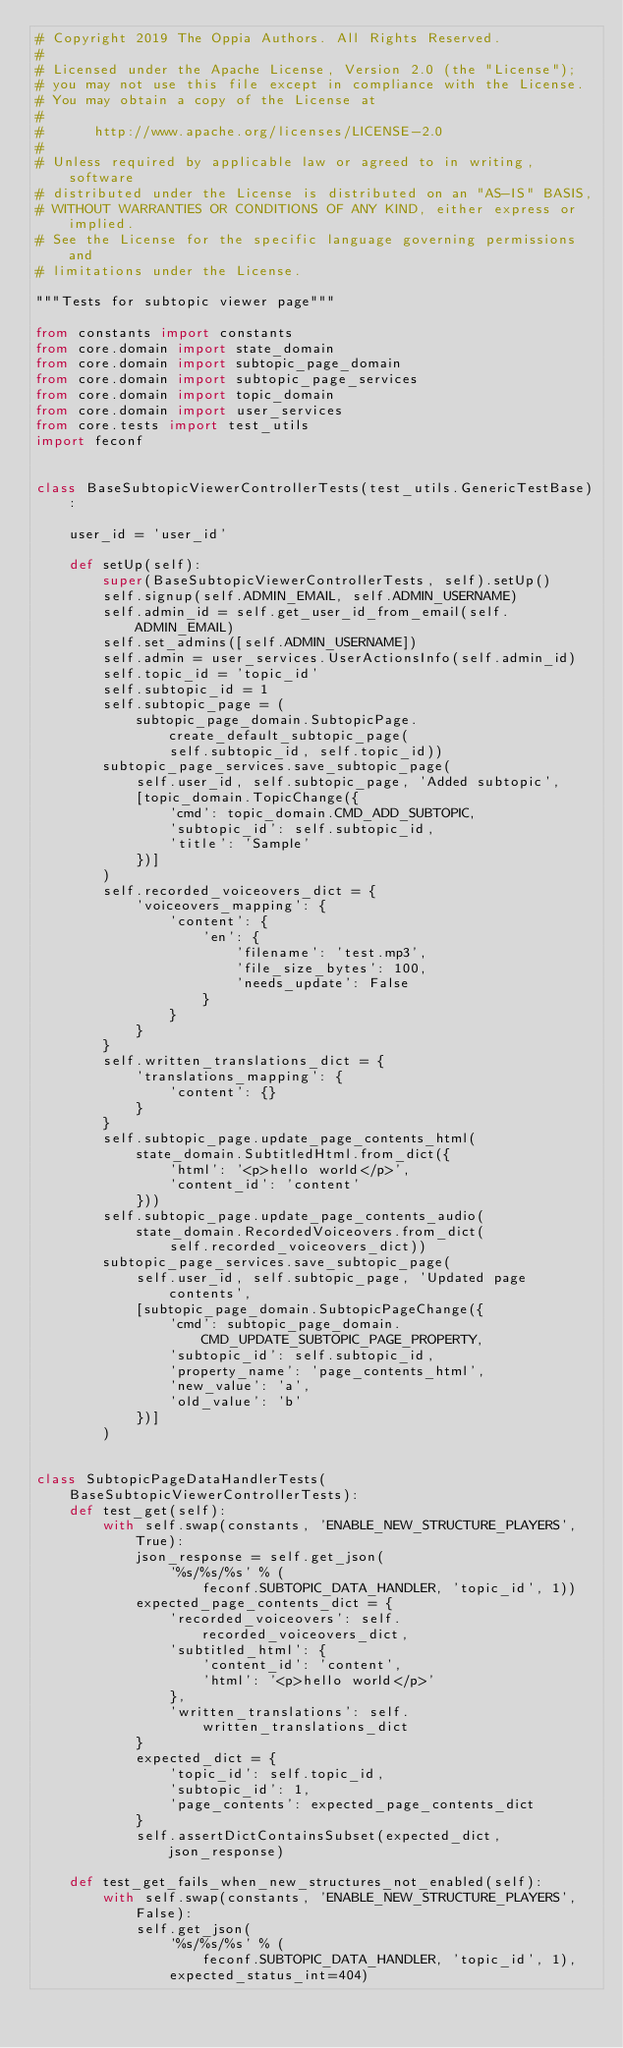Convert code to text. <code><loc_0><loc_0><loc_500><loc_500><_Python_># Copyright 2019 The Oppia Authors. All Rights Reserved.
#
# Licensed under the Apache License, Version 2.0 (the "License");
# you may not use this file except in compliance with the License.
# You may obtain a copy of the License at
#
#      http://www.apache.org/licenses/LICENSE-2.0
#
# Unless required by applicable law or agreed to in writing, software
# distributed under the License is distributed on an "AS-IS" BASIS,
# WITHOUT WARRANTIES OR CONDITIONS OF ANY KIND, either express or implied.
# See the License for the specific language governing permissions and
# limitations under the License.

"""Tests for subtopic viewer page"""

from constants import constants
from core.domain import state_domain
from core.domain import subtopic_page_domain
from core.domain import subtopic_page_services
from core.domain import topic_domain
from core.domain import user_services
from core.tests import test_utils
import feconf


class BaseSubtopicViewerControllerTests(test_utils.GenericTestBase):

    user_id = 'user_id'

    def setUp(self):
        super(BaseSubtopicViewerControllerTests, self).setUp()
        self.signup(self.ADMIN_EMAIL, self.ADMIN_USERNAME)
        self.admin_id = self.get_user_id_from_email(self.ADMIN_EMAIL)
        self.set_admins([self.ADMIN_USERNAME])
        self.admin = user_services.UserActionsInfo(self.admin_id)
        self.topic_id = 'topic_id'
        self.subtopic_id = 1
        self.subtopic_page = (
            subtopic_page_domain.SubtopicPage.create_default_subtopic_page(
                self.subtopic_id, self.topic_id))
        subtopic_page_services.save_subtopic_page(
            self.user_id, self.subtopic_page, 'Added subtopic',
            [topic_domain.TopicChange({
                'cmd': topic_domain.CMD_ADD_SUBTOPIC,
                'subtopic_id': self.subtopic_id,
                'title': 'Sample'
            })]
        )
        self.recorded_voiceovers_dict = {
            'voiceovers_mapping': {
                'content': {
                    'en': {
                        'filename': 'test.mp3',
                        'file_size_bytes': 100,
                        'needs_update': False
                    }
                }
            }
        }
        self.written_translations_dict = {
            'translations_mapping': {
                'content': {}
            }
        }
        self.subtopic_page.update_page_contents_html(
            state_domain.SubtitledHtml.from_dict({
                'html': '<p>hello world</p>',
                'content_id': 'content'
            }))
        self.subtopic_page.update_page_contents_audio(
            state_domain.RecordedVoiceovers.from_dict(
                self.recorded_voiceovers_dict))
        subtopic_page_services.save_subtopic_page(
            self.user_id, self.subtopic_page, 'Updated page contents',
            [subtopic_page_domain.SubtopicPageChange({
                'cmd': subtopic_page_domain.CMD_UPDATE_SUBTOPIC_PAGE_PROPERTY,
                'subtopic_id': self.subtopic_id,
                'property_name': 'page_contents_html',
                'new_value': 'a',
                'old_value': 'b'
            })]
        )


class SubtopicPageDataHandlerTests(BaseSubtopicViewerControllerTests):
    def test_get(self):
        with self.swap(constants, 'ENABLE_NEW_STRUCTURE_PLAYERS', True):
            json_response = self.get_json(
                '%s/%s/%s' % (
                    feconf.SUBTOPIC_DATA_HANDLER, 'topic_id', 1))
            expected_page_contents_dict = {
                'recorded_voiceovers': self.recorded_voiceovers_dict,
                'subtitled_html': {
                    'content_id': 'content',
                    'html': '<p>hello world</p>'
                },
                'written_translations': self.written_translations_dict
            }
            expected_dict = {
                'topic_id': self.topic_id,
                'subtopic_id': 1,
                'page_contents': expected_page_contents_dict
            }
            self.assertDictContainsSubset(expected_dict, json_response)

    def test_get_fails_when_new_structures_not_enabled(self):
        with self.swap(constants, 'ENABLE_NEW_STRUCTURE_PLAYERS', False):
            self.get_json(
                '%s/%s/%s' % (
                    feconf.SUBTOPIC_DATA_HANDLER, 'topic_id', 1),
                expected_status_int=404)
</code> 